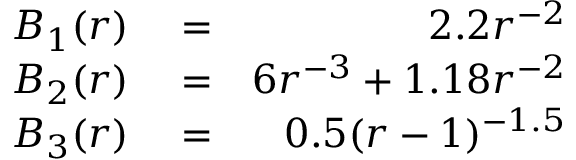<formula> <loc_0><loc_0><loc_500><loc_500>\begin{array} { r l r } { B _ { 1 } ( r ) } & = } & { 2 . 2 r ^ { - 2 } } \\ { B _ { 2 } ( r ) } & = } & { 6 r ^ { - 3 } + 1 . 1 8 r ^ { - 2 } } \\ { B _ { 3 } ( r ) } & = } & { 0 . 5 ( r - 1 ) ^ { - 1 . 5 } } \end{array}</formula> 